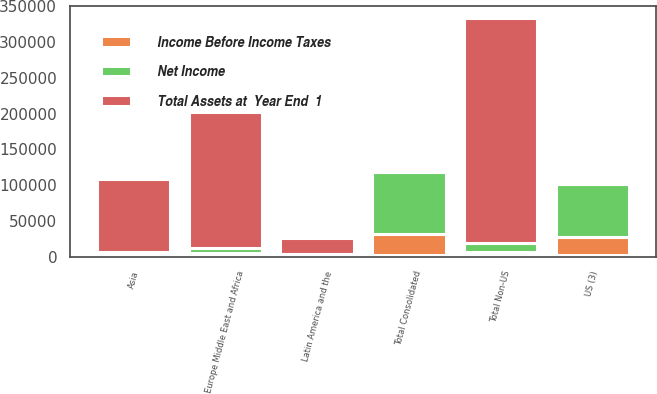Convert chart. <chart><loc_0><loc_0><loc_500><loc_500><stacked_bar_chart><ecel><fcel>US (3)<fcel>Asia<fcel>Europe Middle East and Africa<fcel>Latin America and the<fcel>Total Non-US<fcel>Total Consolidated<nl><fcel>nan<fcel>2017<fcel>2017<fcel>2017<fcel>2017<fcel>2017<fcel>2017<nl><fcel>Total Assets at  Year End  1<fcel>3755<fcel>103255<fcel>189661<fcel>22828<fcel>315744<fcel>3755<nl><fcel>Net Income<fcel>74830<fcel>3405<fcel>7907<fcel>1210<fcel>12522<fcel>87352<nl><fcel>Income Before Income Taxes<fcel>25108<fcel>676<fcel>2990<fcel>439<fcel>4105<fcel>29213<nl></chart> 